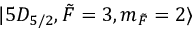<formula> <loc_0><loc_0><loc_500><loc_500>| 5 D _ { 5 / 2 } , \tilde { F } = 3 , m _ { \tilde { F } } = 2 \rangle</formula> 